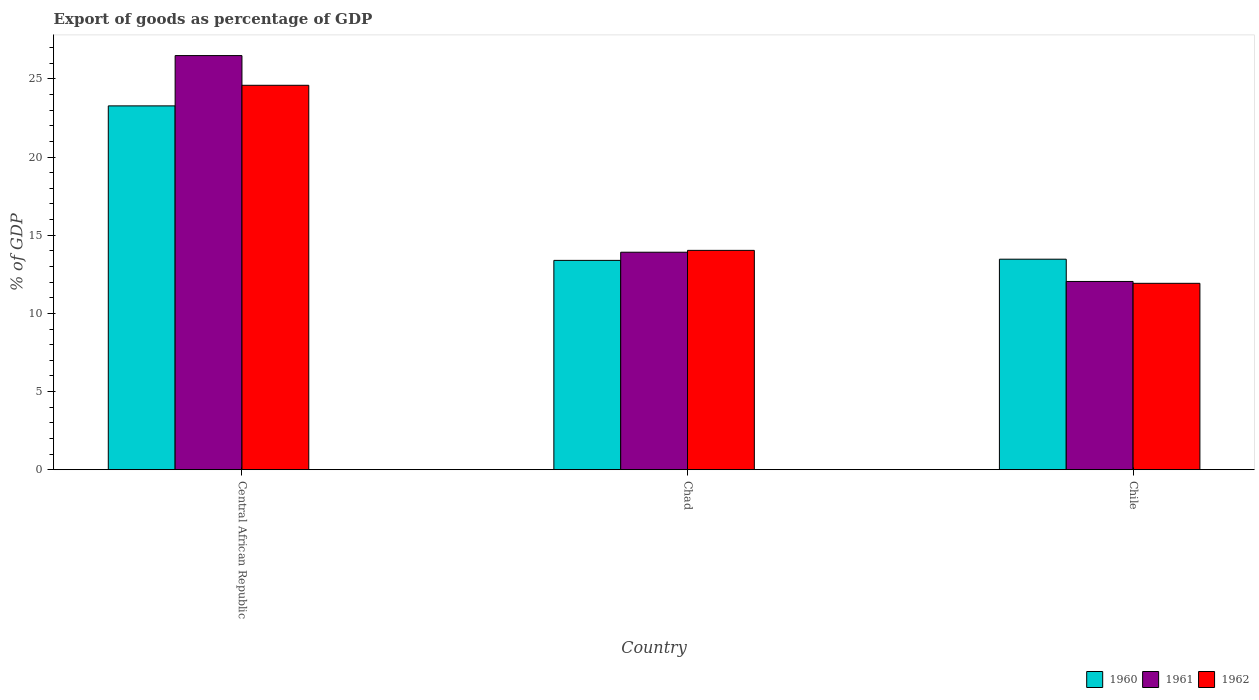How many different coloured bars are there?
Your response must be concise. 3. What is the label of the 2nd group of bars from the left?
Give a very brief answer. Chad. In how many cases, is the number of bars for a given country not equal to the number of legend labels?
Offer a terse response. 0. What is the export of goods as percentage of GDP in 1960 in Central African Republic?
Provide a short and direct response. 23.27. Across all countries, what is the maximum export of goods as percentage of GDP in 1962?
Offer a very short reply. 24.59. Across all countries, what is the minimum export of goods as percentage of GDP in 1960?
Offer a terse response. 13.39. In which country was the export of goods as percentage of GDP in 1960 maximum?
Provide a succinct answer. Central African Republic. In which country was the export of goods as percentage of GDP in 1960 minimum?
Offer a terse response. Chad. What is the total export of goods as percentage of GDP in 1960 in the graph?
Provide a succinct answer. 50.13. What is the difference between the export of goods as percentage of GDP in 1961 in Chad and that in Chile?
Ensure brevity in your answer.  1.87. What is the difference between the export of goods as percentage of GDP in 1961 in Chad and the export of goods as percentage of GDP in 1960 in Central African Republic?
Your response must be concise. -9.36. What is the average export of goods as percentage of GDP in 1961 per country?
Your answer should be compact. 17.48. What is the difference between the export of goods as percentage of GDP of/in 1960 and export of goods as percentage of GDP of/in 1962 in Central African Republic?
Your answer should be compact. -1.32. In how many countries, is the export of goods as percentage of GDP in 1960 greater than 10 %?
Offer a terse response. 3. What is the ratio of the export of goods as percentage of GDP in 1960 in Central African Republic to that in Chile?
Your response must be concise. 1.73. Is the export of goods as percentage of GDP in 1962 in Chad less than that in Chile?
Give a very brief answer. No. Is the difference between the export of goods as percentage of GDP in 1960 in Central African Republic and Chad greater than the difference between the export of goods as percentage of GDP in 1962 in Central African Republic and Chad?
Make the answer very short. No. What is the difference between the highest and the second highest export of goods as percentage of GDP in 1962?
Your answer should be compact. 12.67. What is the difference between the highest and the lowest export of goods as percentage of GDP in 1962?
Your response must be concise. 12.67. In how many countries, is the export of goods as percentage of GDP in 1960 greater than the average export of goods as percentage of GDP in 1960 taken over all countries?
Offer a terse response. 1. What does the 1st bar from the left in Central African Republic represents?
Your answer should be compact. 1960. What does the 3rd bar from the right in Chad represents?
Your answer should be compact. 1960. Does the graph contain any zero values?
Ensure brevity in your answer.  No. Does the graph contain grids?
Your answer should be compact. No. Where does the legend appear in the graph?
Offer a very short reply. Bottom right. What is the title of the graph?
Make the answer very short. Export of goods as percentage of GDP. Does "1995" appear as one of the legend labels in the graph?
Provide a succinct answer. No. What is the label or title of the X-axis?
Offer a terse response. Country. What is the label or title of the Y-axis?
Provide a short and direct response. % of GDP. What is the % of GDP of 1960 in Central African Republic?
Your response must be concise. 23.27. What is the % of GDP in 1961 in Central African Republic?
Offer a very short reply. 26.49. What is the % of GDP of 1962 in Central African Republic?
Ensure brevity in your answer.  24.59. What is the % of GDP in 1960 in Chad?
Offer a terse response. 13.39. What is the % of GDP of 1961 in Chad?
Provide a short and direct response. 13.91. What is the % of GDP in 1962 in Chad?
Keep it short and to the point. 14.03. What is the % of GDP of 1960 in Chile?
Ensure brevity in your answer.  13.47. What is the % of GDP of 1961 in Chile?
Keep it short and to the point. 12.04. What is the % of GDP of 1962 in Chile?
Keep it short and to the point. 11.92. Across all countries, what is the maximum % of GDP in 1960?
Provide a succinct answer. 23.27. Across all countries, what is the maximum % of GDP in 1961?
Keep it short and to the point. 26.49. Across all countries, what is the maximum % of GDP of 1962?
Keep it short and to the point. 24.59. Across all countries, what is the minimum % of GDP in 1960?
Give a very brief answer. 13.39. Across all countries, what is the minimum % of GDP of 1961?
Offer a terse response. 12.04. Across all countries, what is the minimum % of GDP of 1962?
Ensure brevity in your answer.  11.92. What is the total % of GDP of 1960 in the graph?
Your answer should be compact. 50.13. What is the total % of GDP in 1961 in the graph?
Provide a short and direct response. 52.44. What is the total % of GDP in 1962 in the graph?
Provide a short and direct response. 50.54. What is the difference between the % of GDP of 1960 in Central African Republic and that in Chad?
Ensure brevity in your answer.  9.88. What is the difference between the % of GDP of 1961 in Central African Republic and that in Chad?
Your answer should be compact. 12.58. What is the difference between the % of GDP of 1962 in Central African Republic and that in Chad?
Keep it short and to the point. 10.56. What is the difference between the % of GDP of 1960 in Central African Republic and that in Chile?
Offer a terse response. 9.81. What is the difference between the % of GDP in 1961 in Central African Republic and that in Chile?
Offer a very short reply. 14.45. What is the difference between the % of GDP of 1962 in Central African Republic and that in Chile?
Make the answer very short. 12.67. What is the difference between the % of GDP in 1960 in Chad and that in Chile?
Make the answer very short. -0.08. What is the difference between the % of GDP in 1961 in Chad and that in Chile?
Offer a very short reply. 1.87. What is the difference between the % of GDP of 1962 in Chad and that in Chile?
Offer a terse response. 2.11. What is the difference between the % of GDP of 1960 in Central African Republic and the % of GDP of 1961 in Chad?
Your answer should be very brief. 9.36. What is the difference between the % of GDP of 1960 in Central African Republic and the % of GDP of 1962 in Chad?
Ensure brevity in your answer.  9.24. What is the difference between the % of GDP of 1961 in Central African Republic and the % of GDP of 1962 in Chad?
Give a very brief answer. 12.46. What is the difference between the % of GDP in 1960 in Central African Republic and the % of GDP in 1961 in Chile?
Offer a very short reply. 11.23. What is the difference between the % of GDP in 1960 in Central African Republic and the % of GDP in 1962 in Chile?
Keep it short and to the point. 11.35. What is the difference between the % of GDP of 1961 in Central African Republic and the % of GDP of 1962 in Chile?
Provide a succinct answer. 14.57. What is the difference between the % of GDP of 1960 in Chad and the % of GDP of 1961 in Chile?
Give a very brief answer. 1.35. What is the difference between the % of GDP in 1960 in Chad and the % of GDP in 1962 in Chile?
Make the answer very short. 1.47. What is the difference between the % of GDP of 1961 in Chad and the % of GDP of 1962 in Chile?
Offer a very short reply. 1.99. What is the average % of GDP of 1960 per country?
Your answer should be very brief. 16.71. What is the average % of GDP in 1961 per country?
Ensure brevity in your answer.  17.48. What is the average % of GDP in 1962 per country?
Offer a terse response. 16.85. What is the difference between the % of GDP in 1960 and % of GDP in 1961 in Central African Republic?
Offer a terse response. -3.22. What is the difference between the % of GDP in 1960 and % of GDP in 1962 in Central African Republic?
Provide a short and direct response. -1.32. What is the difference between the % of GDP of 1961 and % of GDP of 1962 in Central African Republic?
Keep it short and to the point. 1.9. What is the difference between the % of GDP of 1960 and % of GDP of 1961 in Chad?
Provide a short and direct response. -0.52. What is the difference between the % of GDP of 1960 and % of GDP of 1962 in Chad?
Your response must be concise. -0.64. What is the difference between the % of GDP in 1961 and % of GDP in 1962 in Chad?
Provide a succinct answer. -0.12. What is the difference between the % of GDP of 1960 and % of GDP of 1961 in Chile?
Your answer should be compact. 1.42. What is the difference between the % of GDP of 1960 and % of GDP of 1962 in Chile?
Offer a terse response. 1.54. What is the difference between the % of GDP of 1961 and % of GDP of 1962 in Chile?
Your answer should be very brief. 0.12. What is the ratio of the % of GDP in 1960 in Central African Republic to that in Chad?
Give a very brief answer. 1.74. What is the ratio of the % of GDP of 1961 in Central African Republic to that in Chad?
Your response must be concise. 1.9. What is the ratio of the % of GDP in 1962 in Central African Republic to that in Chad?
Make the answer very short. 1.75. What is the ratio of the % of GDP of 1960 in Central African Republic to that in Chile?
Ensure brevity in your answer.  1.73. What is the ratio of the % of GDP in 1961 in Central African Republic to that in Chile?
Your answer should be compact. 2.2. What is the ratio of the % of GDP of 1962 in Central African Republic to that in Chile?
Your answer should be very brief. 2.06. What is the ratio of the % of GDP of 1961 in Chad to that in Chile?
Offer a terse response. 1.16. What is the ratio of the % of GDP in 1962 in Chad to that in Chile?
Your answer should be compact. 1.18. What is the difference between the highest and the second highest % of GDP of 1960?
Ensure brevity in your answer.  9.81. What is the difference between the highest and the second highest % of GDP in 1961?
Make the answer very short. 12.58. What is the difference between the highest and the second highest % of GDP of 1962?
Provide a succinct answer. 10.56. What is the difference between the highest and the lowest % of GDP of 1960?
Your answer should be compact. 9.88. What is the difference between the highest and the lowest % of GDP in 1961?
Make the answer very short. 14.45. What is the difference between the highest and the lowest % of GDP of 1962?
Provide a succinct answer. 12.67. 